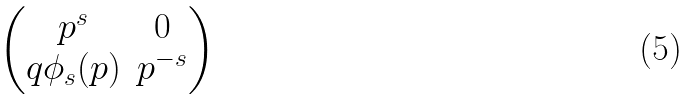<formula> <loc_0><loc_0><loc_500><loc_500>\begin{pmatrix} p ^ { s } & 0 \\ q \phi _ { s } ( p ) & p ^ { - s } \end{pmatrix}</formula> 